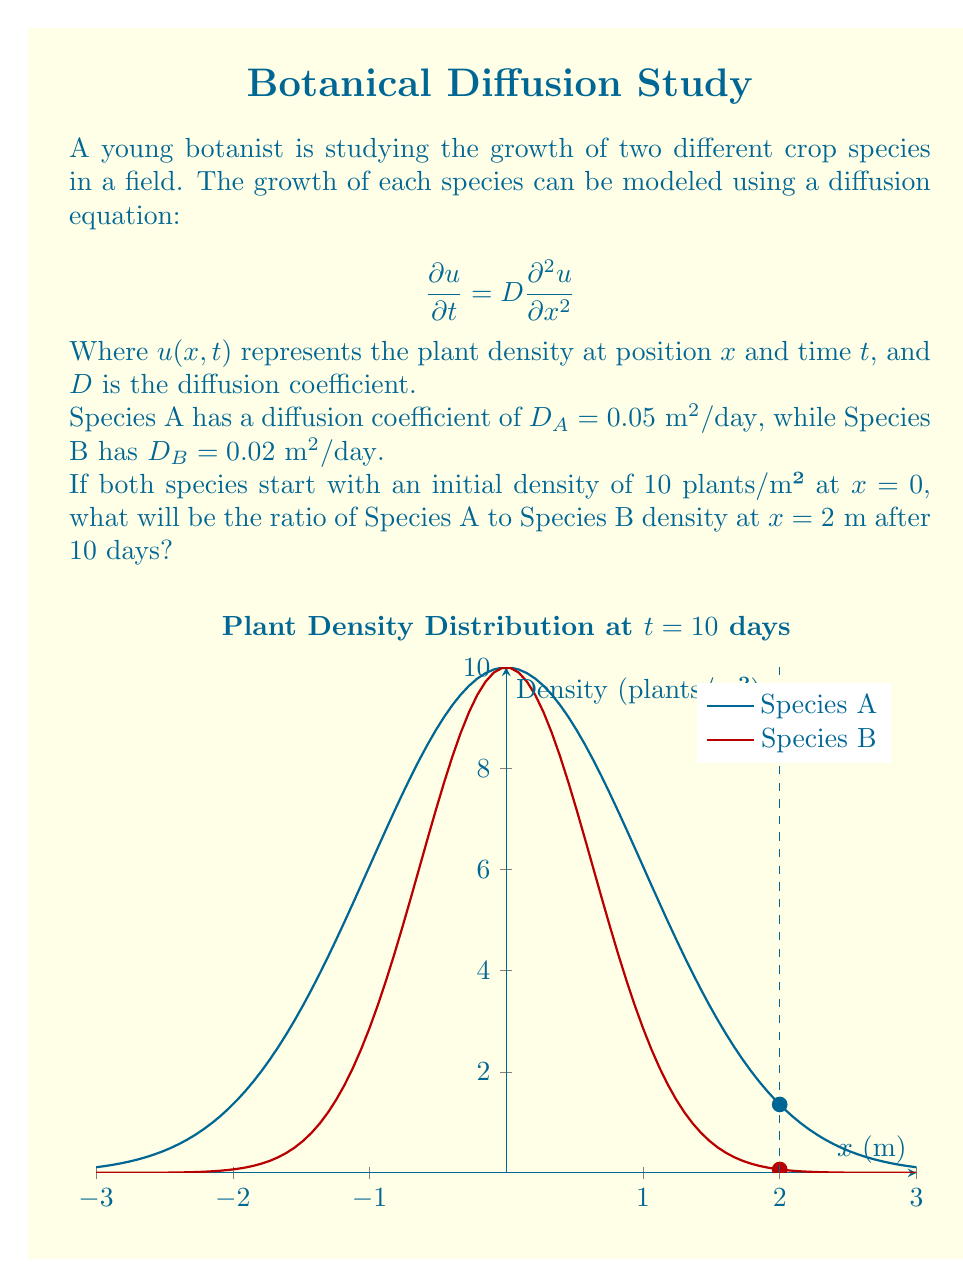What is the answer to this math problem? Let's approach this step-by-step:

1) The solution to the diffusion equation for an initial point source is given by:

   $$u(x,t) = \frac{M}{\sqrt{4\pi Dt}} \exp\left(-\frac{x^2}{4Dt}\right)$$

   Where $M$ is the initial total number of plants (which is not needed for our ratio calculation).

2) For Species A:
   $$u_A(x,t) = \frac{M}{\sqrt{4\pi D_A t}} \exp\left(-\frac{x^2}{4D_A t}\right)$$

3) For Species B:
   $$u_B(x,t) = \frac{M}{\sqrt{4\pi D_B t}} \exp\left(-\frac{x^2}{4D_B t}\right)$$

4) We want to find the ratio $u_A/u_B$ at $x=2\text{ m}$ and $t=10\text{ days}$:

   $$\frac{u_A}{u_B} = \frac{\frac{M}{\sqrt{4\pi D_A t}} \exp\left(-\frac{x^2}{4D_A t}\right)}{\frac{M}{\sqrt{4\pi D_B t}} \exp\left(-\frac{x^2}{4D_B t}\right)}$$

5) The $M$ terms cancel out, and we can simplify:

   $$\frac{u_A}{u_B} = \sqrt{\frac{D_B}{D_A}} \exp\left(\frac{x^2}{4t}\left(\frac{1}{D_B} - \frac{1}{D_A}\right)\right)$$

6) Now, let's substitute the values:
   $D_A = 0.05$, $D_B = 0.02$, $x = 2$, $t = 10$

   $$\frac{u_A}{u_B} = \sqrt{\frac{0.02}{0.05}} \exp\left(\frac{2^2}{4(10)}\left(\frac{1}{0.02} - \frac{1}{0.05}\right)\right)$$

7) Simplify:
   $$\frac{u_A}{u_B} = \sqrt{0.4} \exp\left(0.1(50 - 20)\right) = 0.632 \exp(3) = 12.76$$

Therefore, the density of Species A will be approximately 12.76 times that of Species B at $x=2\text{ m}$ after 10 days.
Answer: 12.76 